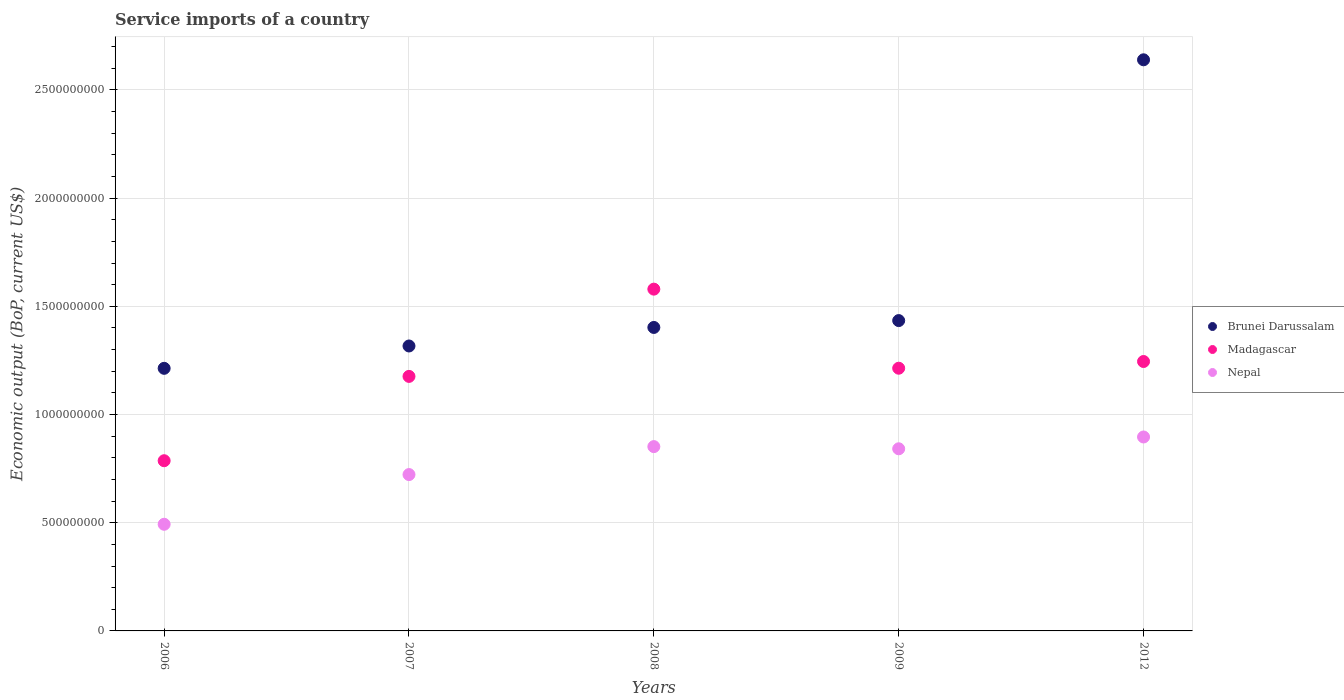Is the number of dotlines equal to the number of legend labels?
Make the answer very short. Yes. What is the service imports in Madagascar in 2012?
Keep it short and to the point. 1.25e+09. Across all years, what is the maximum service imports in Nepal?
Give a very brief answer. 8.96e+08. Across all years, what is the minimum service imports in Brunei Darussalam?
Your answer should be very brief. 1.21e+09. What is the total service imports in Madagascar in the graph?
Provide a succinct answer. 6.00e+09. What is the difference between the service imports in Brunei Darussalam in 2008 and that in 2009?
Offer a terse response. -3.17e+07. What is the difference between the service imports in Madagascar in 2012 and the service imports in Brunei Darussalam in 2009?
Offer a terse response. -1.89e+08. What is the average service imports in Brunei Darussalam per year?
Provide a short and direct response. 1.60e+09. In the year 2008, what is the difference between the service imports in Madagascar and service imports in Brunei Darussalam?
Provide a succinct answer. 1.77e+08. In how many years, is the service imports in Nepal greater than 2600000000 US$?
Offer a very short reply. 0. What is the ratio of the service imports in Brunei Darussalam in 2006 to that in 2007?
Keep it short and to the point. 0.92. Is the difference between the service imports in Madagascar in 2008 and 2009 greater than the difference between the service imports in Brunei Darussalam in 2008 and 2009?
Offer a very short reply. Yes. What is the difference between the highest and the second highest service imports in Brunei Darussalam?
Your answer should be compact. 1.21e+09. What is the difference between the highest and the lowest service imports in Brunei Darussalam?
Keep it short and to the point. 1.43e+09. Is the sum of the service imports in Brunei Darussalam in 2007 and 2012 greater than the maximum service imports in Madagascar across all years?
Provide a succinct answer. Yes. Does the service imports in Madagascar monotonically increase over the years?
Give a very brief answer. No. Is the service imports in Nepal strictly less than the service imports in Brunei Darussalam over the years?
Provide a short and direct response. Yes. How many dotlines are there?
Ensure brevity in your answer.  3. What is the difference between two consecutive major ticks on the Y-axis?
Provide a short and direct response. 5.00e+08. Does the graph contain any zero values?
Your answer should be compact. No. Does the graph contain grids?
Make the answer very short. Yes. How are the legend labels stacked?
Offer a very short reply. Vertical. What is the title of the graph?
Keep it short and to the point. Service imports of a country. Does "Maldives" appear as one of the legend labels in the graph?
Provide a short and direct response. No. What is the label or title of the X-axis?
Offer a terse response. Years. What is the label or title of the Y-axis?
Offer a very short reply. Economic output (BoP, current US$). What is the Economic output (BoP, current US$) of Brunei Darussalam in 2006?
Provide a succinct answer. 1.21e+09. What is the Economic output (BoP, current US$) of Madagascar in 2006?
Give a very brief answer. 7.87e+08. What is the Economic output (BoP, current US$) in Nepal in 2006?
Make the answer very short. 4.93e+08. What is the Economic output (BoP, current US$) in Brunei Darussalam in 2007?
Ensure brevity in your answer.  1.32e+09. What is the Economic output (BoP, current US$) of Madagascar in 2007?
Your response must be concise. 1.18e+09. What is the Economic output (BoP, current US$) of Nepal in 2007?
Ensure brevity in your answer.  7.23e+08. What is the Economic output (BoP, current US$) in Brunei Darussalam in 2008?
Your answer should be very brief. 1.40e+09. What is the Economic output (BoP, current US$) of Madagascar in 2008?
Your answer should be compact. 1.58e+09. What is the Economic output (BoP, current US$) of Nepal in 2008?
Ensure brevity in your answer.  8.52e+08. What is the Economic output (BoP, current US$) of Brunei Darussalam in 2009?
Offer a very short reply. 1.43e+09. What is the Economic output (BoP, current US$) of Madagascar in 2009?
Your response must be concise. 1.21e+09. What is the Economic output (BoP, current US$) of Nepal in 2009?
Provide a succinct answer. 8.42e+08. What is the Economic output (BoP, current US$) in Brunei Darussalam in 2012?
Provide a short and direct response. 2.64e+09. What is the Economic output (BoP, current US$) of Madagascar in 2012?
Offer a very short reply. 1.25e+09. What is the Economic output (BoP, current US$) in Nepal in 2012?
Make the answer very short. 8.96e+08. Across all years, what is the maximum Economic output (BoP, current US$) in Brunei Darussalam?
Offer a very short reply. 2.64e+09. Across all years, what is the maximum Economic output (BoP, current US$) in Madagascar?
Keep it short and to the point. 1.58e+09. Across all years, what is the maximum Economic output (BoP, current US$) of Nepal?
Your answer should be compact. 8.96e+08. Across all years, what is the minimum Economic output (BoP, current US$) of Brunei Darussalam?
Your answer should be compact. 1.21e+09. Across all years, what is the minimum Economic output (BoP, current US$) in Madagascar?
Offer a very short reply. 7.87e+08. Across all years, what is the minimum Economic output (BoP, current US$) in Nepal?
Offer a very short reply. 4.93e+08. What is the total Economic output (BoP, current US$) of Brunei Darussalam in the graph?
Your answer should be very brief. 8.01e+09. What is the total Economic output (BoP, current US$) in Madagascar in the graph?
Keep it short and to the point. 6.00e+09. What is the total Economic output (BoP, current US$) in Nepal in the graph?
Your answer should be very brief. 3.81e+09. What is the difference between the Economic output (BoP, current US$) of Brunei Darussalam in 2006 and that in 2007?
Give a very brief answer. -1.03e+08. What is the difference between the Economic output (BoP, current US$) of Madagascar in 2006 and that in 2007?
Provide a succinct answer. -3.90e+08. What is the difference between the Economic output (BoP, current US$) of Nepal in 2006 and that in 2007?
Provide a short and direct response. -2.30e+08. What is the difference between the Economic output (BoP, current US$) of Brunei Darussalam in 2006 and that in 2008?
Provide a succinct answer. -1.89e+08. What is the difference between the Economic output (BoP, current US$) of Madagascar in 2006 and that in 2008?
Offer a terse response. -7.93e+08. What is the difference between the Economic output (BoP, current US$) in Nepal in 2006 and that in 2008?
Keep it short and to the point. -3.59e+08. What is the difference between the Economic output (BoP, current US$) in Brunei Darussalam in 2006 and that in 2009?
Provide a short and direct response. -2.21e+08. What is the difference between the Economic output (BoP, current US$) of Madagascar in 2006 and that in 2009?
Offer a terse response. -4.27e+08. What is the difference between the Economic output (BoP, current US$) of Nepal in 2006 and that in 2009?
Provide a short and direct response. -3.49e+08. What is the difference between the Economic output (BoP, current US$) in Brunei Darussalam in 2006 and that in 2012?
Provide a short and direct response. -1.43e+09. What is the difference between the Economic output (BoP, current US$) in Madagascar in 2006 and that in 2012?
Provide a short and direct response. -4.59e+08. What is the difference between the Economic output (BoP, current US$) in Nepal in 2006 and that in 2012?
Your response must be concise. -4.03e+08. What is the difference between the Economic output (BoP, current US$) in Brunei Darussalam in 2007 and that in 2008?
Your response must be concise. -8.57e+07. What is the difference between the Economic output (BoP, current US$) of Madagascar in 2007 and that in 2008?
Make the answer very short. -4.03e+08. What is the difference between the Economic output (BoP, current US$) in Nepal in 2007 and that in 2008?
Give a very brief answer. -1.29e+08. What is the difference between the Economic output (BoP, current US$) of Brunei Darussalam in 2007 and that in 2009?
Offer a terse response. -1.17e+08. What is the difference between the Economic output (BoP, current US$) of Madagascar in 2007 and that in 2009?
Keep it short and to the point. -3.78e+07. What is the difference between the Economic output (BoP, current US$) in Nepal in 2007 and that in 2009?
Provide a short and direct response. -1.19e+08. What is the difference between the Economic output (BoP, current US$) of Brunei Darussalam in 2007 and that in 2012?
Ensure brevity in your answer.  -1.32e+09. What is the difference between the Economic output (BoP, current US$) of Madagascar in 2007 and that in 2012?
Give a very brief answer. -6.88e+07. What is the difference between the Economic output (BoP, current US$) in Nepal in 2007 and that in 2012?
Your answer should be very brief. -1.74e+08. What is the difference between the Economic output (BoP, current US$) in Brunei Darussalam in 2008 and that in 2009?
Your answer should be compact. -3.17e+07. What is the difference between the Economic output (BoP, current US$) in Madagascar in 2008 and that in 2009?
Offer a terse response. 3.65e+08. What is the difference between the Economic output (BoP, current US$) in Nepal in 2008 and that in 2009?
Keep it short and to the point. 1.00e+07. What is the difference between the Economic output (BoP, current US$) in Brunei Darussalam in 2008 and that in 2012?
Give a very brief answer. -1.24e+09. What is the difference between the Economic output (BoP, current US$) in Madagascar in 2008 and that in 2012?
Give a very brief answer. 3.34e+08. What is the difference between the Economic output (BoP, current US$) of Nepal in 2008 and that in 2012?
Your answer should be very brief. -4.45e+07. What is the difference between the Economic output (BoP, current US$) of Brunei Darussalam in 2009 and that in 2012?
Make the answer very short. -1.21e+09. What is the difference between the Economic output (BoP, current US$) in Madagascar in 2009 and that in 2012?
Provide a succinct answer. -3.10e+07. What is the difference between the Economic output (BoP, current US$) in Nepal in 2009 and that in 2012?
Provide a short and direct response. -5.46e+07. What is the difference between the Economic output (BoP, current US$) in Brunei Darussalam in 2006 and the Economic output (BoP, current US$) in Madagascar in 2007?
Make the answer very short. 3.73e+07. What is the difference between the Economic output (BoP, current US$) of Brunei Darussalam in 2006 and the Economic output (BoP, current US$) of Nepal in 2007?
Provide a short and direct response. 4.91e+08. What is the difference between the Economic output (BoP, current US$) in Madagascar in 2006 and the Economic output (BoP, current US$) in Nepal in 2007?
Offer a very short reply. 6.40e+07. What is the difference between the Economic output (BoP, current US$) of Brunei Darussalam in 2006 and the Economic output (BoP, current US$) of Madagascar in 2008?
Your answer should be compact. -3.66e+08. What is the difference between the Economic output (BoP, current US$) in Brunei Darussalam in 2006 and the Economic output (BoP, current US$) in Nepal in 2008?
Your response must be concise. 3.62e+08. What is the difference between the Economic output (BoP, current US$) in Madagascar in 2006 and the Economic output (BoP, current US$) in Nepal in 2008?
Give a very brief answer. -6.52e+07. What is the difference between the Economic output (BoP, current US$) in Brunei Darussalam in 2006 and the Economic output (BoP, current US$) in Madagascar in 2009?
Your answer should be compact. -5.01e+05. What is the difference between the Economic output (BoP, current US$) of Brunei Darussalam in 2006 and the Economic output (BoP, current US$) of Nepal in 2009?
Your response must be concise. 3.72e+08. What is the difference between the Economic output (BoP, current US$) of Madagascar in 2006 and the Economic output (BoP, current US$) of Nepal in 2009?
Make the answer very short. -5.51e+07. What is the difference between the Economic output (BoP, current US$) of Brunei Darussalam in 2006 and the Economic output (BoP, current US$) of Madagascar in 2012?
Keep it short and to the point. -3.15e+07. What is the difference between the Economic output (BoP, current US$) in Brunei Darussalam in 2006 and the Economic output (BoP, current US$) in Nepal in 2012?
Your answer should be very brief. 3.17e+08. What is the difference between the Economic output (BoP, current US$) of Madagascar in 2006 and the Economic output (BoP, current US$) of Nepal in 2012?
Your response must be concise. -1.10e+08. What is the difference between the Economic output (BoP, current US$) in Brunei Darussalam in 2007 and the Economic output (BoP, current US$) in Madagascar in 2008?
Keep it short and to the point. -2.63e+08. What is the difference between the Economic output (BoP, current US$) in Brunei Darussalam in 2007 and the Economic output (BoP, current US$) in Nepal in 2008?
Make the answer very short. 4.65e+08. What is the difference between the Economic output (BoP, current US$) in Madagascar in 2007 and the Economic output (BoP, current US$) in Nepal in 2008?
Keep it short and to the point. 3.25e+08. What is the difference between the Economic output (BoP, current US$) of Brunei Darussalam in 2007 and the Economic output (BoP, current US$) of Madagascar in 2009?
Offer a terse response. 1.03e+08. What is the difference between the Economic output (BoP, current US$) in Brunei Darussalam in 2007 and the Economic output (BoP, current US$) in Nepal in 2009?
Offer a terse response. 4.75e+08. What is the difference between the Economic output (BoP, current US$) in Madagascar in 2007 and the Economic output (BoP, current US$) in Nepal in 2009?
Make the answer very short. 3.35e+08. What is the difference between the Economic output (BoP, current US$) of Brunei Darussalam in 2007 and the Economic output (BoP, current US$) of Madagascar in 2012?
Provide a short and direct response. 7.18e+07. What is the difference between the Economic output (BoP, current US$) in Brunei Darussalam in 2007 and the Economic output (BoP, current US$) in Nepal in 2012?
Your answer should be compact. 4.21e+08. What is the difference between the Economic output (BoP, current US$) in Madagascar in 2007 and the Economic output (BoP, current US$) in Nepal in 2012?
Provide a short and direct response. 2.80e+08. What is the difference between the Economic output (BoP, current US$) in Brunei Darussalam in 2008 and the Economic output (BoP, current US$) in Madagascar in 2009?
Give a very brief answer. 1.88e+08. What is the difference between the Economic output (BoP, current US$) in Brunei Darussalam in 2008 and the Economic output (BoP, current US$) in Nepal in 2009?
Your answer should be very brief. 5.61e+08. What is the difference between the Economic output (BoP, current US$) in Madagascar in 2008 and the Economic output (BoP, current US$) in Nepal in 2009?
Your answer should be very brief. 7.38e+08. What is the difference between the Economic output (BoP, current US$) in Brunei Darussalam in 2008 and the Economic output (BoP, current US$) in Madagascar in 2012?
Your answer should be compact. 1.57e+08. What is the difference between the Economic output (BoP, current US$) in Brunei Darussalam in 2008 and the Economic output (BoP, current US$) in Nepal in 2012?
Ensure brevity in your answer.  5.06e+08. What is the difference between the Economic output (BoP, current US$) in Madagascar in 2008 and the Economic output (BoP, current US$) in Nepal in 2012?
Give a very brief answer. 6.83e+08. What is the difference between the Economic output (BoP, current US$) of Brunei Darussalam in 2009 and the Economic output (BoP, current US$) of Madagascar in 2012?
Your response must be concise. 1.89e+08. What is the difference between the Economic output (BoP, current US$) of Brunei Darussalam in 2009 and the Economic output (BoP, current US$) of Nepal in 2012?
Your answer should be very brief. 5.38e+08. What is the difference between the Economic output (BoP, current US$) of Madagascar in 2009 and the Economic output (BoP, current US$) of Nepal in 2012?
Offer a terse response. 3.18e+08. What is the average Economic output (BoP, current US$) in Brunei Darussalam per year?
Keep it short and to the point. 1.60e+09. What is the average Economic output (BoP, current US$) in Madagascar per year?
Your answer should be compact. 1.20e+09. What is the average Economic output (BoP, current US$) in Nepal per year?
Provide a short and direct response. 7.61e+08. In the year 2006, what is the difference between the Economic output (BoP, current US$) in Brunei Darussalam and Economic output (BoP, current US$) in Madagascar?
Your response must be concise. 4.27e+08. In the year 2006, what is the difference between the Economic output (BoP, current US$) of Brunei Darussalam and Economic output (BoP, current US$) of Nepal?
Your answer should be compact. 7.21e+08. In the year 2006, what is the difference between the Economic output (BoP, current US$) of Madagascar and Economic output (BoP, current US$) of Nepal?
Keep it short and to the point. 2.94e+08. In the year 2007, what is the difference between the Economic output (BoP, current US$) in Brunei Darussalam and Economic output (BoP, current US$) in Madagascar?
Keep it short and to the point. 1.41e+08. In the year 2007, what is the difference between the Economic output (BoP, current US$) of Brunei Darussalam and Economic output (BoP, current US$) of Nepal?
Give a very brief answer. 5.94e+08. In the year 2007, what is the difference between the Economic output (BoP, current US$) of Madagascar and Economic output (BoP, current US$) of Nepal?
Provide a short and direct response. 4.54e+08. In the year 2008, what is the difference between the Economic output (BoP, current US$) in Brunei Darussalam and Economic output (BoP, current US$) in Madagascar?
Your answer should be compact. -1.77e+08. In the year 2008, what is the difference between the Economic output (BoP, current US$) of Brunei Darussalam and Economic output (BoP, current US$) of Nepal?
Ensure brevity in your answer.  5.51e+08. In the year 2008, what is the difference between the Economic output (BoP, current US$) in Madagascar and Economic output (BoP, current US$) in Nepal?
Make the answer very short. 7.28e+08. In the year 2009, what is the difference between the Economic output (BoP, current US$) of Brunei Darussalam and Economic output (BoP, current US$) of Madagascar?
Offer a terse response. 2.20e+08. In the year 2009, what is the difference between the Economic output (BoP, current US$) of Brunei Darussalam and Economic output (BoP, current US$) of Nepal?
Keep it short and to the point. 5.92e+08. In the year 2009, what is the difference between the Economic output (BoP, current US$) in Madagascar and Economic output (BoP, current US$) in Nepal?
Give a very brief answer. 3.72e+08. In the year 2012, what is the difference between the Economic output (BoP, current US$) in Brunei Darussalam and Economic output (BoP, current US$) in Madagascar?
Your answer should be compact. 1.39e+09. In the year 2012, what is the difference between the Economic output (BoP, current US$) of Brunei Darussalam and Economic output (BoP, current US$) of Nepal?
Give a very brief answer. 1.74e+09. In the year 2012, what is the difference between the Economic output (BoP, current US$) of Madagascar and Economic output (BoP, current US$) of Nepal?
Provide a short and direct response. 3.49e+08. What is the ratio of the Economic output (BoP, current US$) in Brunei Darussalam in 2006 to that in 2007?
Make the answer very short. 0.92. What is the ratio of the Economic output (BoP, current US$) in Madagascar in 2006 to that in 2007?
Offer a terse response. 0.67. What is the ratio of the Economic output (BoP, current US$) of Nepal in 2006 to that in 2007?
Make the answer very short. 0.68. What is the ratio of the Economic output (BoP, current US$) of Brunei Darussalam in 2006 to that in 2008?
Your answer should be compact. 0.87. What is the ratio of the Economic output (BoP, current US$) of Madagascar in 2006 to that in 2008?
Make the answer very short. 0.5. What is the ratio of the Economic output (BoP, current US$) in Nepal in 2006 to that in 2008?
Your answer should be very brief. 0.58. What is the ratio of the Economic output (BoP, current US$) of Brunei Darussalam in 2006 to that in 2009?
Your answer should be very brief. 0.85. What is the ratio of the Economic output (BoP, current US$) of Madagascar in 2006 to that in 2009?
Give a very brief answer. 0.65. What is the ratio of the Economic output (BoP, current US$) in Nepal in 2006 to that in 2009?
Offer a terse response. 0.59. What is the ratio of the Economic output (BoP, current US$) of Brunei Darussalam in 2006 to that in 2012?
Provide a succinct answer. 0.46. What is the ratio of the Economic output (BoP, current US$) in Madagascar in 2006 to that in 2012?
Your answer should be very brief. 0.63. What is the ratio of the Economic output (BoP, current US$) in Nepal in 2006 to that in 2012?
Give a very brief answer. 0.55. What is the ratio of the Economic output (BoP, current US$) in Brunei Darussalam in 2007 to that in 2008?
Your answer should be compact. 0.94. What is the ratio of the Economic output (BoP, current US$) in Madagascar in 2007 to that in 2008?
Keep it short and to the point. 0.74. What is the ratio of the Economic output (BoP, current US$) of Nepal in 2007 to that in 2008?
Your answer should be very brief. 0.85. What is the ratio of the Economic output (BoP, current US$) of Brunei Darussalam in 2007 to that in 2009?
Give a very brief answer. 0.92. What is the ratio of the Economic output (BoP, current US$) in Madagascar in 2007 to that in 2009?
Your answer should be compact. 0.97. What is the ratio of the Economic output (BoP, current US$) in Nepal in 2007 to that in 2009?
Your response must be concise. 0.86. What is the ratio of the Economic output (BoP, current US$) of Brunei Darussalam in 2007 to that in 2012?
Give a very brief answer. 0.5. What is the ratio of the Economic output (BoP, current US$) in Madagascar in 2007 to that in 2012?
Provide a short and direct response. 0.94. What is the ratio of the Economic output (BoP, current US$) in Nepal in 2007 to that in 2012?
Offer a very short reply. 0.81. What is the ratio of the Economic output (BoP, current US$) of Brunei Darussalam in 2008 to that in 2009?
Offer a very short reply. 0.98. What is the ratio of the Economic output (BoP, current US$) in Madagascar in 2008 to that in 2009?
Offer a terse response. 1.3. What is the ratio of the Economic output (BoP, current US$) in Nepal in 2008 to that in 2009?
Your response must be concise. 1.01. What is the ratio of the Economic output (BoP, current US$) in Brunei Darussalam in 2008 to that in 2012?
Ensure brevity in your answer.  0.53. What is the ratio of the Economic output (BoP, current US$) of Madagascar in 2008 to that in 2012?
Your response must be concise. 1.27. What is the ratio of the Economic output (BoP, current US$) in Nepal in 2008 to that in 2012?
Make the answer very short. 0.95. What is the ratio of the Economic output (BoP, current US$) in Brunei Darussalam in 2009 to that in 2012?
Your answer should be compact. 0.54. What is the ratio of the Economic output (BoP, current US$) in Madagascar in 2009 to that in 2012?
Offer a very short reply. 0.98. What is the ratio of the Economic output (BoP, current US$) in Nepal in 2009 to that in 2012?
Your response must be concise. 0.94. What is the difference between the highest and the second highest Economic output (BoP, current US$) in Brunei Darussalam?
Your answer should be very brief. 1.21e+09. What is the difference between the highest and the second highest Economic output (BoP, current US$) in Madagascar?
Provide a succinct answer. 3.34e+08. What is the difference between the highest and the second highest Economic output (BoP, current US$) of Nepal?
Your answer should be very brief. 4.45e+07. What is the difference between the highest and the lowest Economic output (BoP, current US$) of Brunei Darussalam?
Give a very brief answer. 1.43e+09. What is the difference between the highest and the lowest Economic output (BoP, current US$) of Madagascar?
Your response must be concise. 7.93e+08. What is the difference between the highest and the lowest Economic output (BoP, current US$) of Nepal?
Ensure brevity in your answer.  4.03e+08. 